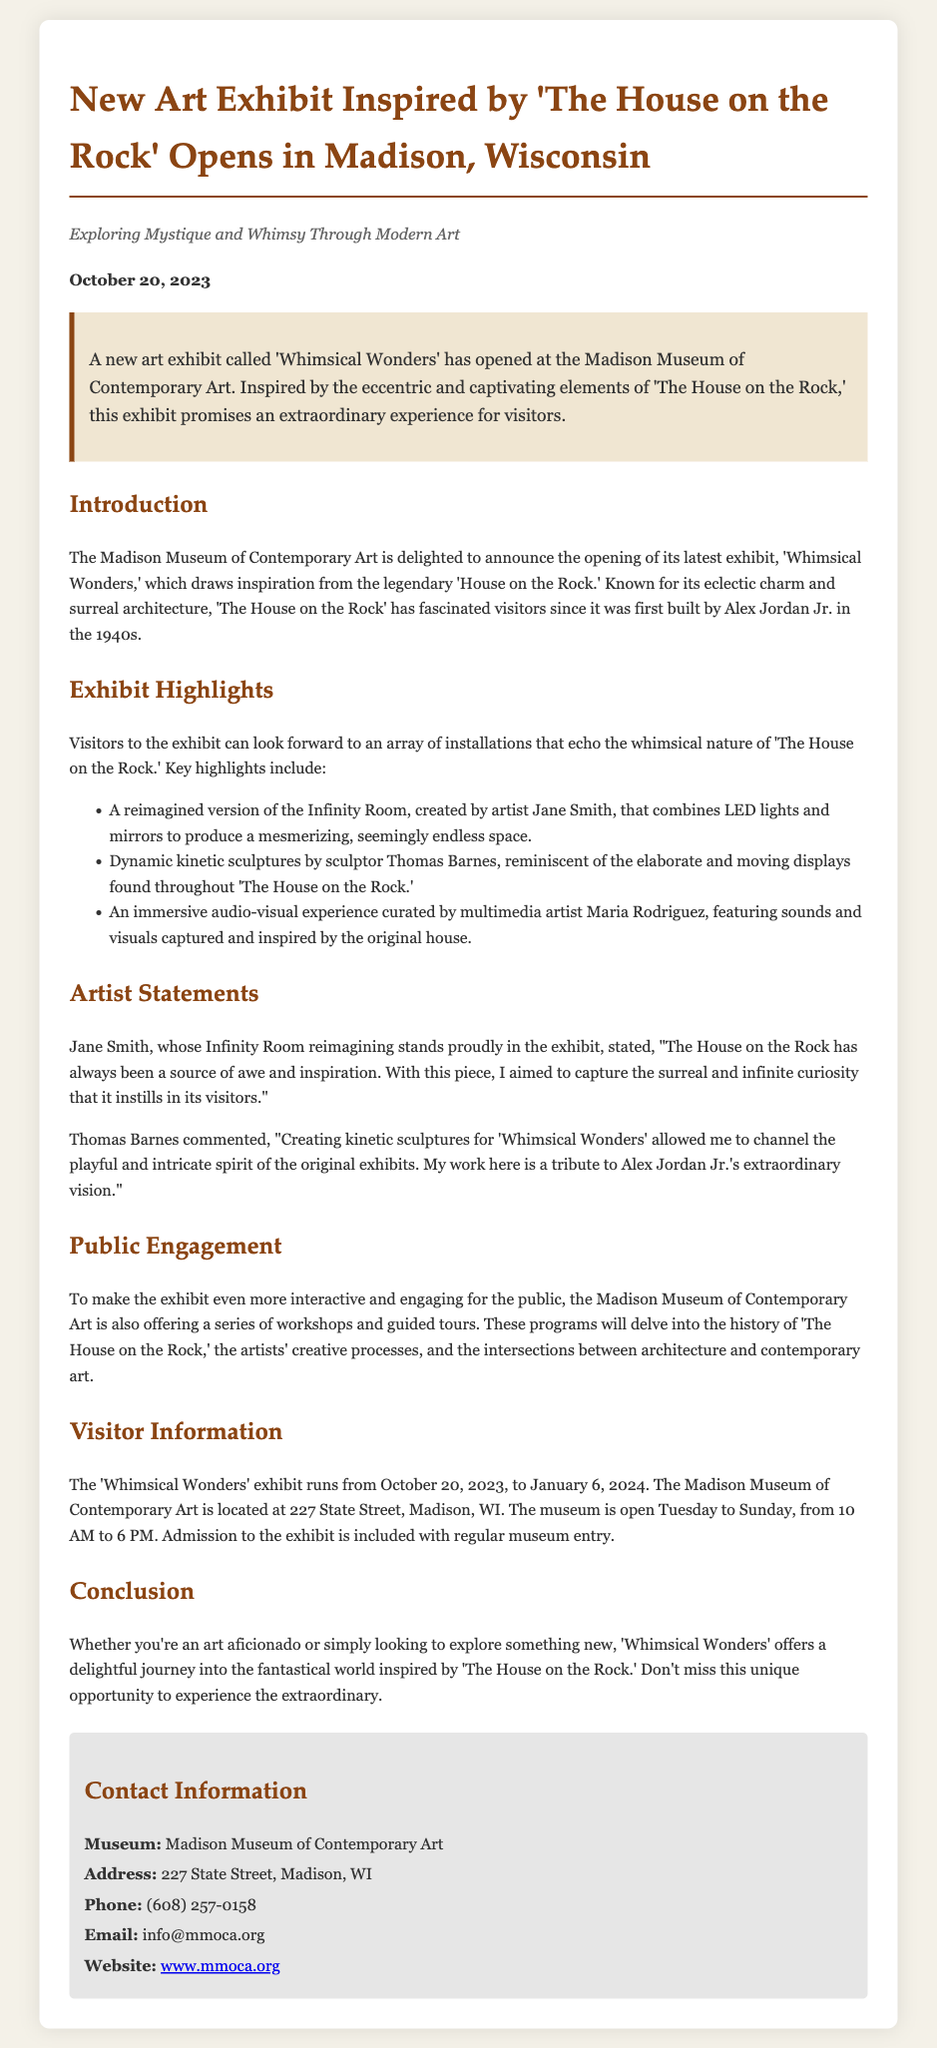What is the title of the new art exhibit? The title of the new art exhibit is mentioned in the heading of the document.
Answer: 'Whimsical Wonders' Who created the reimagined version of the Infinity Room? The document specifies that Jane Smith is the artist who created the reimagined Infinity Room.
Answer: Jane Smith When does the exhibit 'Whimsical Wonders' end? The ending date of the exhibit is provided in the visitor information section of the document.
Answer: January 6, 2024 What is the location of the Madison Museum of Contemporary Art? The address of the museum is stated in the contact information section.
Answer: 227 State Street, Madison, WI What does Thomas Barnes's work in the exhibit represent? The document notes that his kinetic sculptures are a tribute to Alex Jordan Jr.'s vision.
Answer: Tribute to Alex Jordan Jr.'s vision How does the exhibit engage with the public? The document describes workshops and guided tours that aim to engage the public with the exhibit.
Answer: Workshops and guided tours What type of art can visitors expect to see at the exhibit? The document highlights installations that echo the whimsical nature of 'The House on the Rock.'
Answer: Whimsical installations What are the museum's open days? The document provides information about the days the museum is open.
Answer: Tuesday to Sunday 